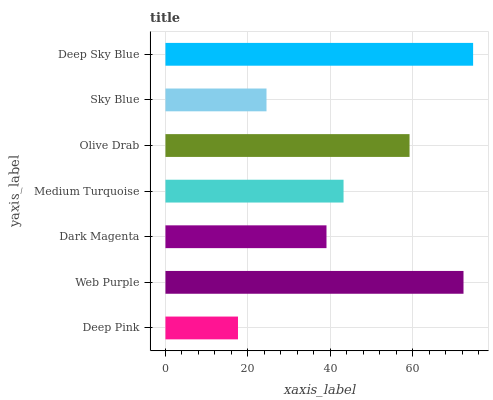Is Deep Pink the minimum?
Answer yes or no. Yes. Is Deep Sky Blue the maximum?
Answer yes or no. Yes. Is Web Purple the minimum?
Answer yes or no. No. Is Web Purple the maximum?
Answer yes or no. No. Is Web Purple greater than Deep Pink?
Answer yes or no. Yes. Is Deep Pink less than Web Purple?
Answer yes or no. Yes. Is Deep Pink greater than Web Purple?
Answer yes or no. No. Is Web Purple less than Deep Pink?
Answer yes or no. No. Is Medium Turquoise the high median?
Answer yes or no. Yes. Is Medium Turquoise the low median?
Answer yes or no. Yes. Is Olive Drab the high median?
Answer yes or no. No. Is Olive Drab the low median?
Answer yes or no. No. 